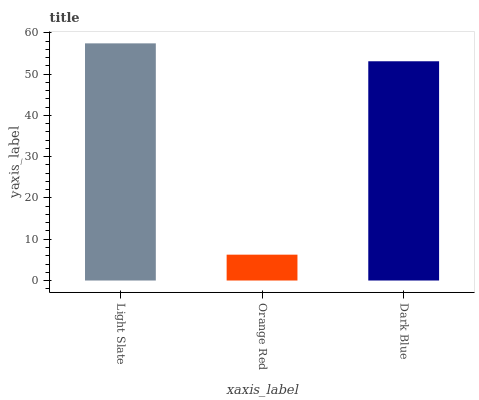Is Orange Red the minimum?
Answer yes or no. Yes. Is Light Slate the maximum?
Answer yes or no. Yes. Is Dark Blue the minimum?
Answer yes or no. No. Is Dark Blue the maximum?
Answer yes or no. No. Is Dark Blue greater than Orange Red?
Answer yes or no. Yes. Is Orange Red less than Dark Blue?
Answer yes or no. Yes. Is Orange Red greater than Dark Blue?
Answer yes or no. No. Is Dark Blue less than Orange Red?
Answer yes or no. No. Is Dark Blue the high median?
Answer yes or no. Yes. Is Dark Blue the low median?
Answer yes or no. Yes. Is Light Slate the high median?
Answer yes or no. No. Is Light Slate the low median?
Answer yes or no. No. 